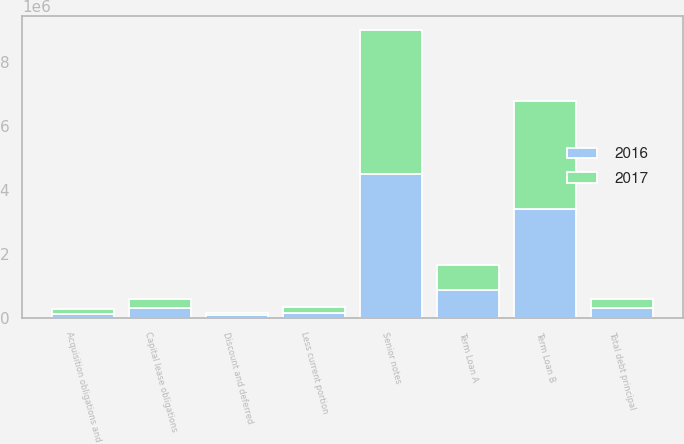Convert chart to OTSL. <chart><loc_0><loc_0><loc_500><loc_500><stacked_bar_chart><ecel><fcel>Term Loan A<fcel>Term Loan B<fcel>Senior notes<fcel>Acquisition obligations and<fcel>Capital lease obligations<fcel>Total debt principal<fcel>Discount and deferred<fcel>Less current portion<nl><fcel>2017<fcel>775000<fcel>3.3775e+06<fcel>4.5e+06<fcel>150512<fcel>297170<fcel>294711<fcel>63951<fcel>178213<nl><fcel>2016<fcel>862500<fcel>3.4125e+06<fcel>4.5e+06<fcel>117547<fcel>292252<fcel>294711<fcel>79861<fcel>160262<nl></chart> 